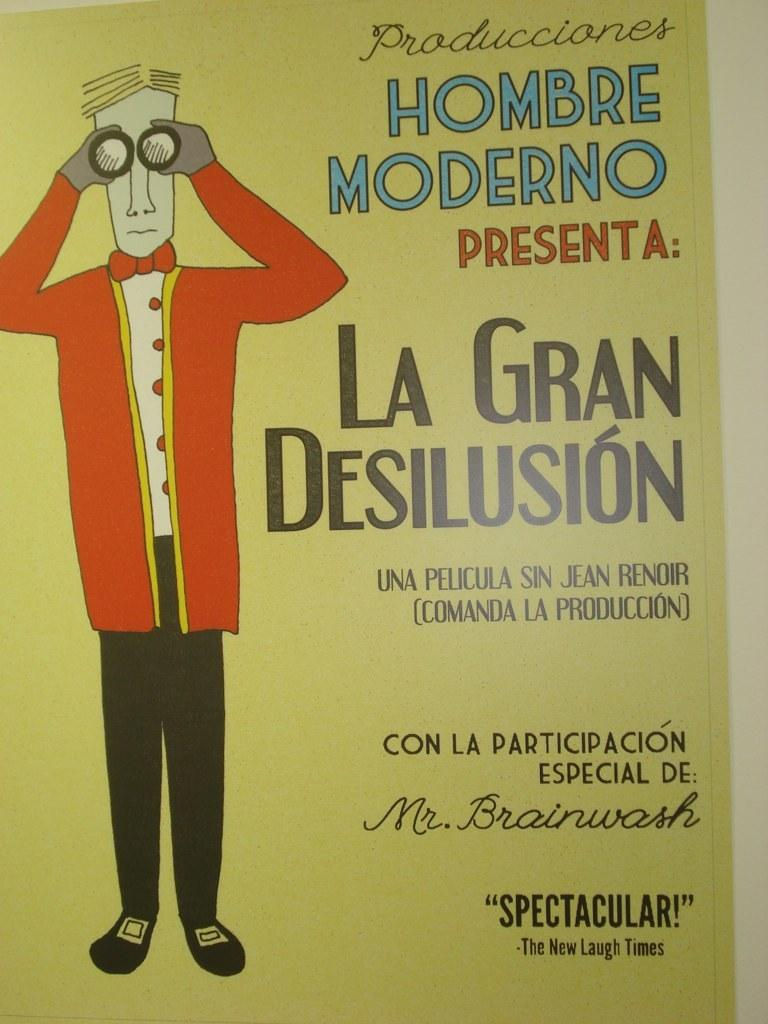What is present in the picture? There is a poster in the picture. What can be seen in the poster? The poster contains a picture of a person. Are there any words on the poster? Yes, there are words on the poster. What type of bone can be seen in the picture? There is no bone present in the picture; it only contains a poster with a picture of a person and some words. 